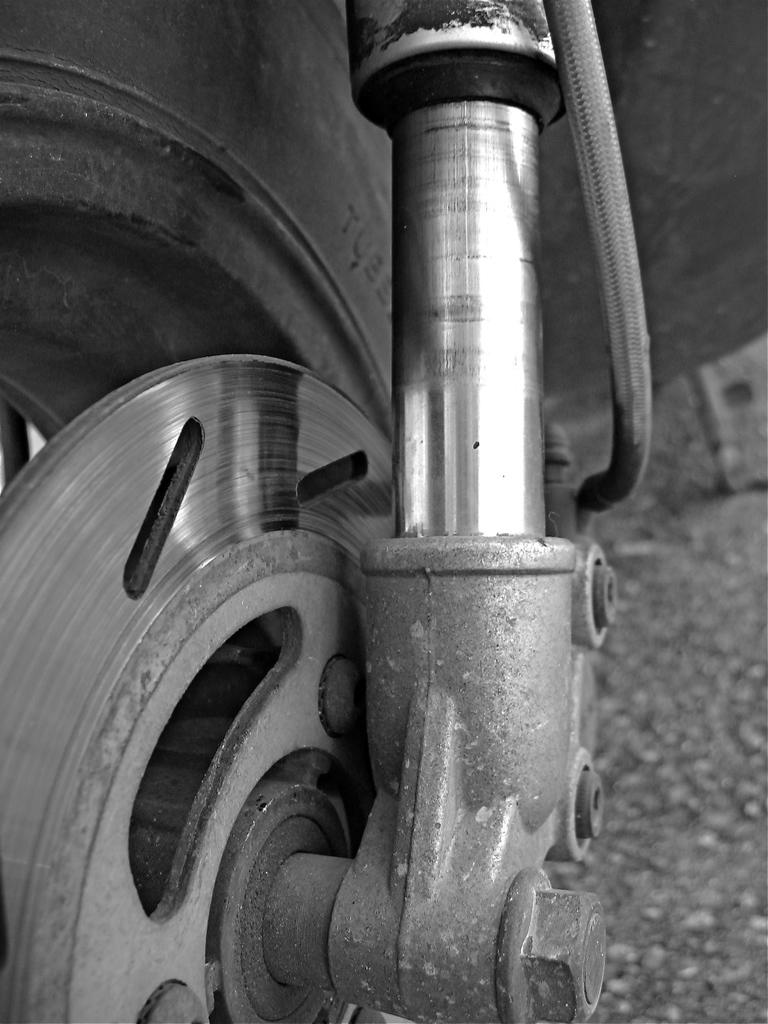What is the color scheme of the image? The image is black and white. What is the main subject of the image? The image is a zoomed in picture of a bike wheel. What type of stone is visible in the image? There is no stone present in the image; it is a zoomed in picture of a bike wheel. What part of a celery plant can be seen in the image? There is no celery plant present in the image; it is a zoomed in picture of a bike wheel. 